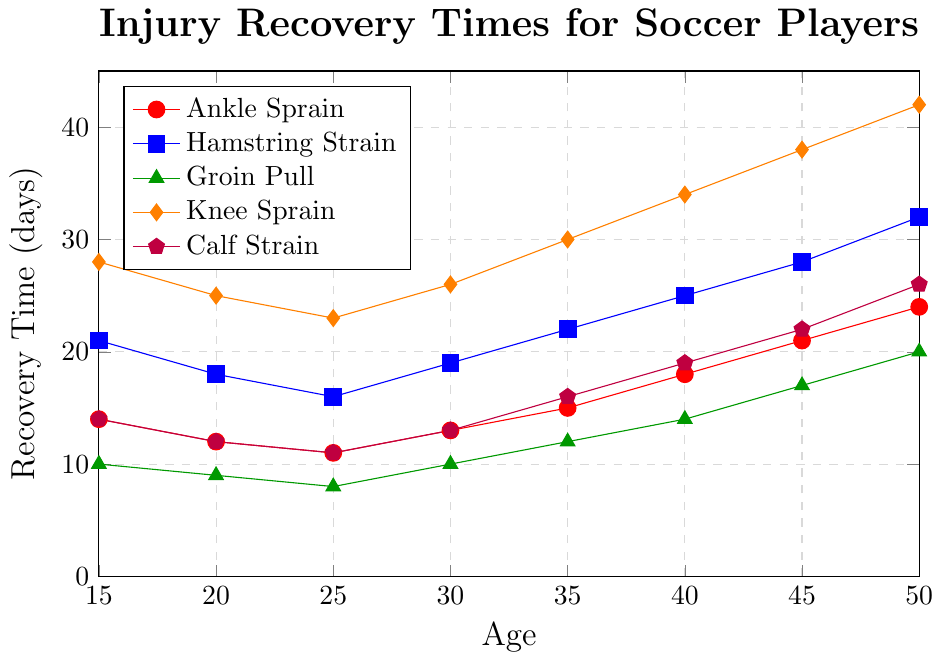Which age group has the shortest recovery time for a Hamstring Strain? Look at the Hamstring Strain line (blue) and find the lowest point. The minimum recovery time of 16 days happens at age 25.
Answer: 25 What is the difference in recovery time for a Knee Sprain between ages 15 and 50? Look at the Knee Sprain line (orange) and note the values at ages 15 and 50, which are 28 days and 42 days respectively. Subtract the values: 42 - 28 = 14 days.
Answer: 14 days How does the recovery time for an Ankle Sprain change between ages 20 and 40? Look at the Ankle Sprain line (red) and compare the values at ages 20 and 40, which are 12 days and 18 days respectively. Subtract the two values: 18 - 12 = 6 days.
Answer: Increases by 6 days Which injury has the most significant increase in recovery time as age increases from 15 to 50? Compare the increase in recovery times for all injuries from age 15 to age 50. Knee Sprain increases from 28 days to 42 days, which is a 14-day increase, the largest among the injuries.
Answer: Knee Sprain At age 35, which injury has the shortest recovery time? Look at the values for all injuries at age 35. The Groin Pull has the shortest recovery time at 12 days.
Answer: Groin Pull What is the average recovery time for a Calf Strain between ages 15 and 50? Look at the Calf Strain line (purple) and note the values: 14, 12, 11, 13, 16, 19, 22, 26. Calculate the average: (14 + 12 + 11 + 13 + 16 + 19 + 22 + 26) / 8 = 16.625 days.
Answer: 16.625 days By how many days does the recovery time for a Groin Pull increase from age 30 to age 45? Find the Groin Pull values at ages 30 and 45, which are 10 days and 17 days respectively. Subtract the two values: 17 - 10 = 7 days.
Answer: 7 days Which injury shows the least variation in recovery times across age groups? Compare the variability of the recovery times for each injury. Ankle Sprain has values of 14, 12, 11, 13, 15, 18, 21, 24, showing the least variation.
Answer: Ankle Sprain 